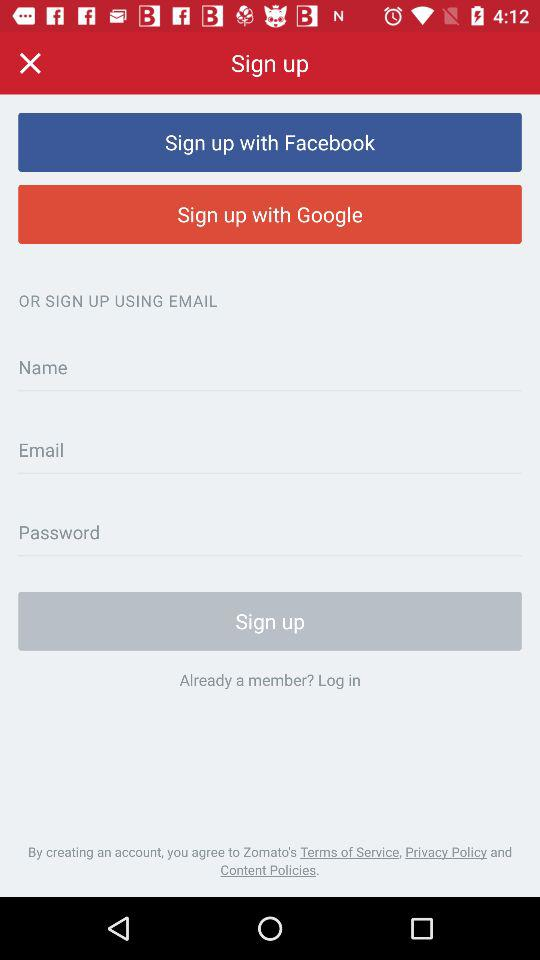Through which accounts can sign up be done? Sign up can be done through "Facebook", "Google" and "EMAIL". 